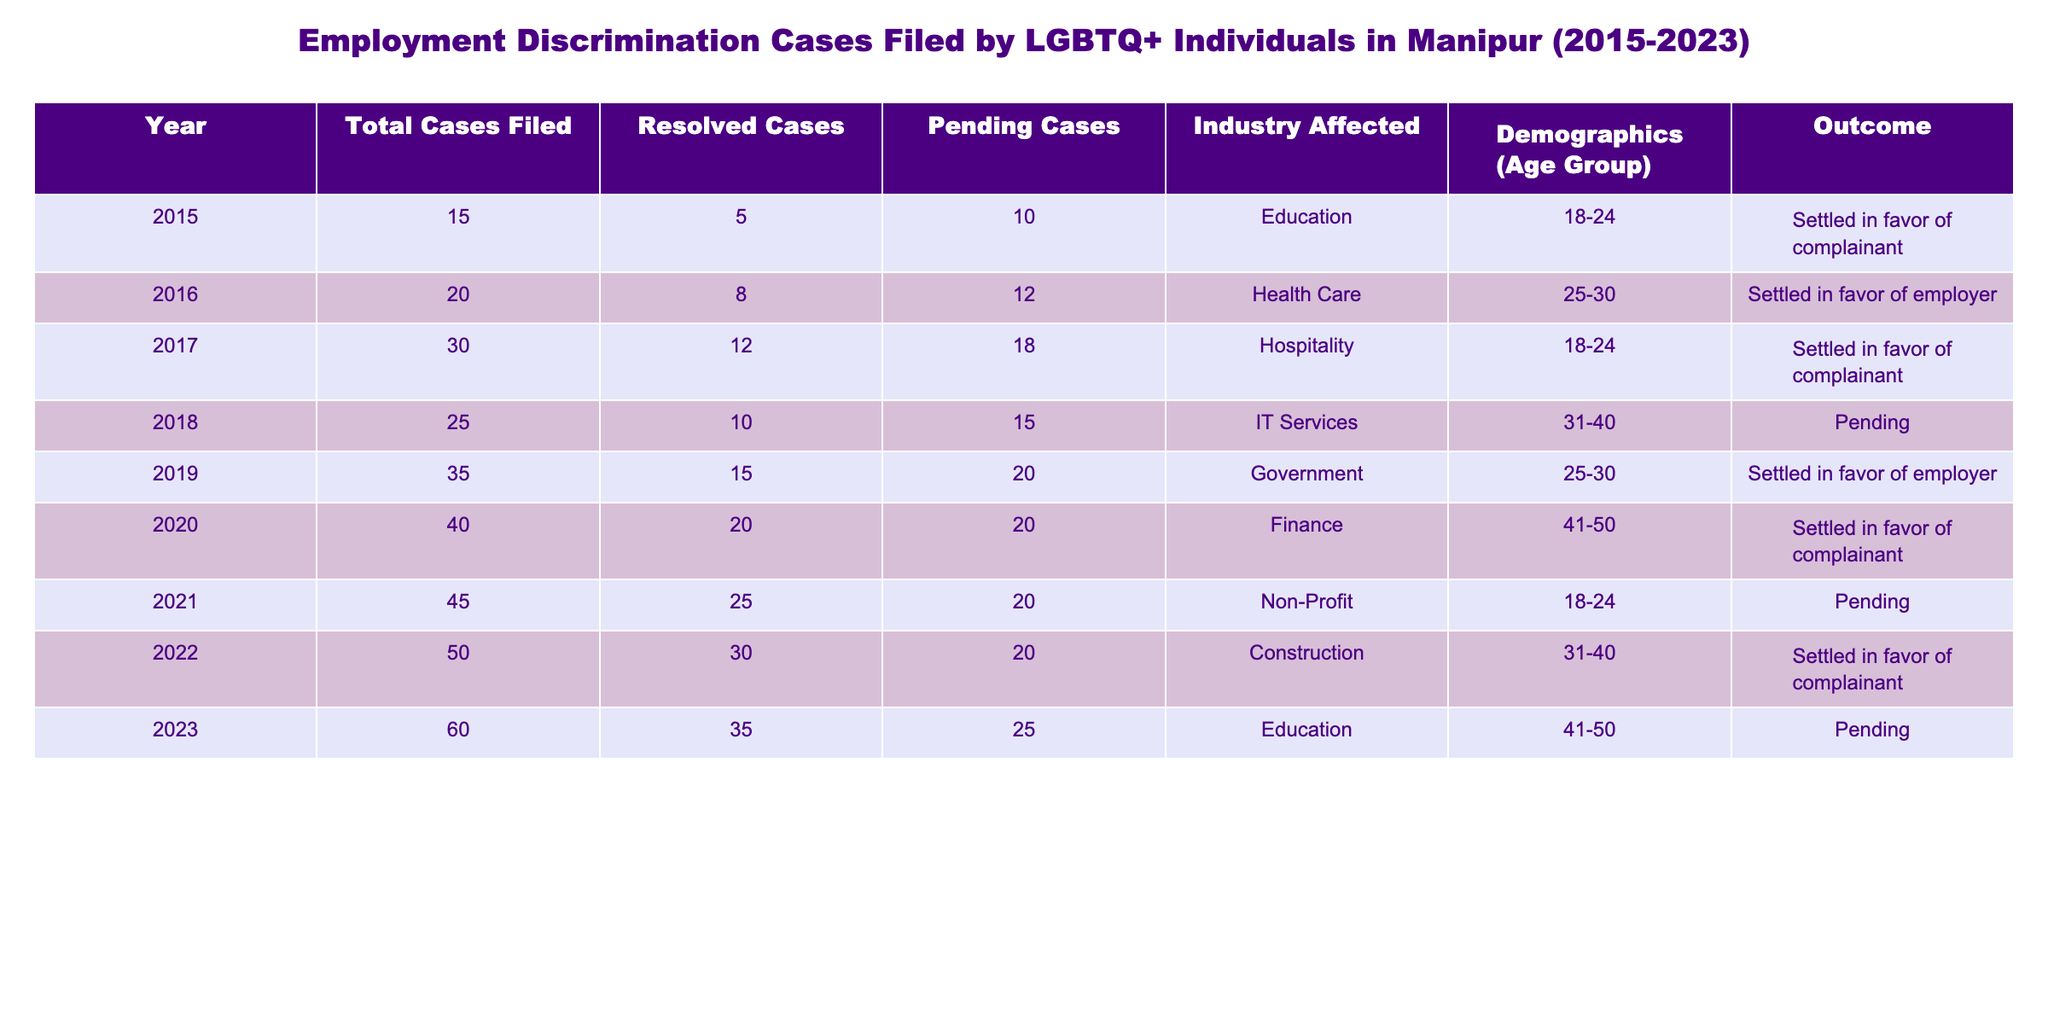What was the total number of employment discrimination cases filed by LGBTQ+ individuals in 2018? From the table, we can directly refer to the year 2018, where the column for Total Cases Filed shows a value of 25.
Answer: 25 In which industry did the highest number of cases occur, and how many were filed? To determine this, we can look at the Total Cases Filed for each industry. The highest number is 60 cases filed in the Education sector in 2023.
Answer: Education, 60 What percentage of cases filed in 2021 were resolved? In 2021, there were 45 total cases and 25 resolved cases. To find the percentage, we divide the resolved cases by total cases: (25/45) * 100 = 55.56%.
Answer: 55.56% How many more cases were pending in 2023 compared to 2015? In 2023, there were 25 pending cases and in 2015, there were 10 pending cases. The difference is 25 - 10 = 15 more cases pending in 2023 compared to 2015.
Answer: 15 Did the number of settled cases in favor of employers increase over the years? We look for cases settled in favor of employers across all years in the table. They appeared in 2016 (8), 2019 (15), but did not consistently increase as there were years with no cases favoring employers. Therefore, it is not consistent.
Answer: No 